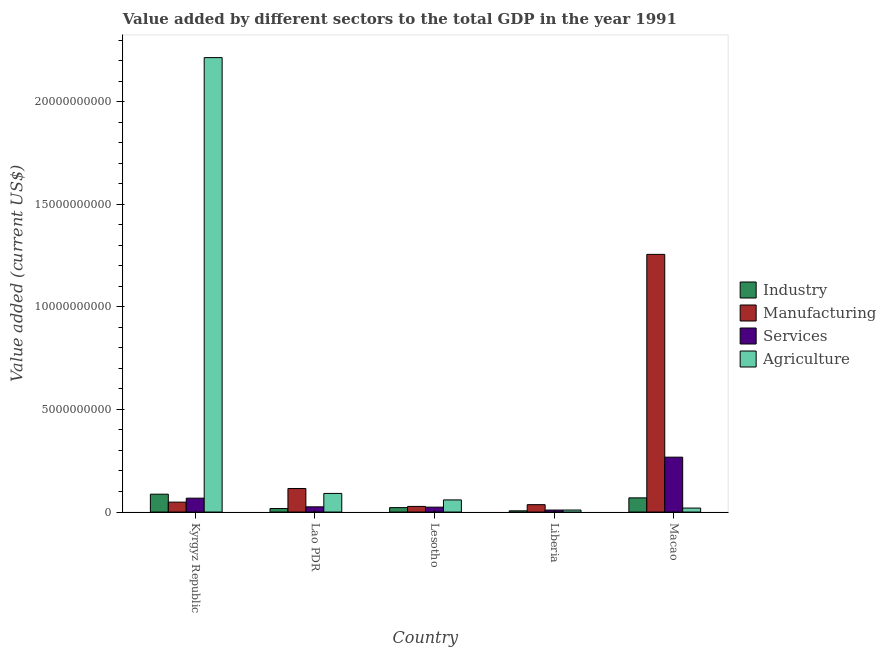Are the number of bars per tick equal to the number of legend labels?
Ensure brevity in your answer.  Yes. How many bars are there on the 3rd tick from the left?
Keep it short and to the point. 4. What is the label of the 5th group of bars from the left?
Provide a short and direct response. Macao. What is the value added by manufacturing sector in Lesotho?
Offer a very short reply. 2.74e+08. Across all countries, what is the maximum value added by agricultural sector?
Offer a terse response. 2.21e+1. Across all countries, what is the minimum value added by agricultural sector?
Offer a terse response. 9.75e+07. In which country was the value added by industrial sector maximum?
Make the answer very short. Kyrgyz Republic. In which country was the value added by industrial sector minimum?
Keep it short and to the point. Liberia. What is the total value added by agricultural sector in the graph?
Offer a very short reply. 2.39e+1. What is the difference between the value added by manufacturing sector in Kyrgyz Republic and that in Liberia?
Keep it short and to the point. 1.23e+08. What is the difference between the value added by agricultural sector in Macao and the value added by services sector in Kyrgyz Republic?
Your response must be concise. -4.82e+08. What is the average value added by industrial sector per country?
Your answer should be very brief. 4.01e+08. What is the difference between the value added by manufacturing sector and value added by agricultural sector in Macao?
Ensure brevity in your answer.  1.24e+1. In how many countries, is the value added by agricultural sector greater than 5000000000 US$?
Your response must be concise. 1. What is the ratio of the value added by industrial sector in Lao PDR to that in Liberia?
Offer a very short reply. 2.92. What is the difference between the highest and the second highest value added by agricultural sector?
Offer a terse response. 2.12e+1. What is the difference between the highest and the lowest value added by agricultural sector?
Provide a short and direct response. 2.20e+1. Is the sum of the value added by industrial sector in Lao PDR and Macao greater than the maximum value added by services sector across all countries?
Make the answer very short. No. What does the 1st bar from the left in Macao represents?
Your answer should be very brief. Industry. What does the 1st bar from the right in Lao PDR represents?
Keep it short and to the point. Agriculture. How many bars are there?
Your response must be concise. 20. Does the graph contain any zero values?
Your answer should be compact. No. Does the graph contain grids?
Provide a succinct answer. No. Where does the legend appear in the graph?
Your answer should be compact. Center right. What is the title of the graph?
Offer a very short reply. Value added by different sectors to the total GDP in the year 1991. Does "Salary of employees" appear as one of the legend labels in the graph?
Offer a terse response. No. What is the label or title of the Y-axis?
Make the answer very short. Value added (current US$). What is the Value added (current US$) of Industry in Kyrgyz Republic?
Make the answer very short. 8.69e+08. What is the Value added (current US$) of Manufacturing in Kyrgyz Republic?
Make the answer very short. 4.82e+08. What is the Value added (current US$) in Services in Kyrgyz Republic?
Provide a short and direct response. 6.76e+08. What is the Value added (current US$) in Agriculture in Kyrgyz Republic?
Your answer should be very brief. 2.21e+1. What is the Value added (current US$) in Industry in Lao PDR?
Your answer should be very brief. 1.70e+08. What is the Value added (current US$) in Manufacturing in Lao PDR?
Provide a succinct answer. 1.15e+09. What is the Value added (current US$) in Services in Lao PDR?
Offer a terse response. 2.53e+08. What is the Value added (current US$) in Agriculture in Lao PDR?
Provide a short and direct response. 9.06e+08. What is the Value added (current US$) of Industry in Lesotho?
Keep it short and to the point. 2.15e+08. What is the Value added (current US$) of Manufacturing in Lesotho?
Provide a short and direct response. 2.74e+08. What is the Value added (current US$) in Services in Lesotho?
Your response must be concise. 2.38e+08. What is the Value added (current US$) of Agriculture in Lesotho?
Keep it short and to the point. 5.90e+08. What is the Value added (current US$) of Industry in Liberia?
Give a very brief answer. 5.83e+07. What is the Value added (current US$) in Manufacturing in Liberia?
Your answer should be very brief. 3.59e+08. What is the Value added (current US$) in Services in Liberia?
Keep it short and to the point. 9.62e+07. What is the Value added (current US$) of Agriculture in Liberia?
Your answer should be very brief. 9.75e+07. What is the Value added (current US$) in Industry in Macao?
Your answer should be very brief. 6.91e+08. What is the Value added (current US$) in Manufacturing in Macao?
Keep it short and to the point. 1.26e+1. What is the Value added (current US$) in Services in Macao?
Provide a short and direct response. 2.67e+09. What is the Value added (current US$) of Agriculture in Macao?
Provide a succinct answer. 1.94e+08. Across all countries, what is the maximum Value added (current US$) in Industry?
Make the answer very short. 8.69e+08. Across all countries, what is the maximum Value added (current US$) of Manufacturing?
Offer a terse response. 1.26e+1. Across all countries, what is the maximum Value added (current US$) in Services?
Offer a very short reply. 2.67e+09. Across all countries, what is the maximum Value added (current US$) in Agriculture?
Your answer should be very brief. 2.21e+1. Across all countries, what is the minimum Value added (current US$) in Industry?
Provide a short and direct response. 5.83e+07. Across all countries, what is the minimum Value added (current US$) in Manufacturing?
Your response must be concise. 2.74e+08. Across all countries, what is the minimum Value added (current US$) in Services?
Give a very brief answer. 9.62e+07. Across all countries, what is the minimum Value added (current US$) in Agriculture?
Offer a very short reply. 9.75e+07. What is the total Value added (current US$) of Industry in the graph?
Provide a short and direct response. 2.00e+09. What is the total Value added (current US$) in Manufacturing in the graph?
Make the answer very short. 1.48e+1. What is the total Value added (current US$) in Services in the graph?
Ensure brevity in your answer.  3.94e+09. What is the total Value added (current US$) of Agriculture in the graph?
Your answer should be compact. 2.39e+1. What is the difference between the Value added (current US$) in Industry in Kyrgyz Republic and that in Lao PDR?
Offer a very short reply. 6.99e+08. What is the difference between the Value added (current US$) of Manufacturing in Kyrgyz Republic and that in Lao PDR?
Offer a very short reply. -6.65e+08. What is the difference between the Value added (current US$) in Services in Kyrgyz Republic and that in Lao PDR?
Provide a short and direct response. 4.23e+08. What is the difference between the Value added (current US$) in Agriculture in Kyrgyz Republic and that in Lao PDR?
Ensure brevity in your answer.  2.12e+1. What is the difference between the Value added (current US$) of Industry in Kyrgyz Republic and that in Lesotho?
Make the answer very short. 6.54e+08. What is the difference between the Value added (current US$) of Manufacturing in Kyrgyz Republic and that in Lesotho?
Your answer should be compact. 2.08e+08. What is the difference between the Value added (current US$) of Services in Kyrgyz Republic and that in Lesotho?
Provide a short and direct response. 4.38e+08. What is the difference between the Value added (current US$) in Agriculture in Kyrgyz Republic and that in Lesotho?
Keep it short and to the point. 2.16e+1. What is the difference between the Value added (current US$) in Industry in Kyrgyz Republic and that in Liberia?
Offer a terse response. 8.11e+08. What is the difference between the Value added (current US$) in Manufacturing in Kyrgyz Republic and that in Liberia?
Offer a very short reply. 1.23e+08. What is the difference between the Value added (current US$) of Services in Kyrgyz Republic and that in Liberia?
Provide a short and direct response. 5.80e+08. What is the difference between the Value added (current US$) of Agriculture in Kyrgyz Republic and that in Liberia?
Your answer should be compact. 2.20e+1. What is the difference between the Value added (current US$) in Industry in Kyrgyz Republic and that in Macao?
Provide a succinct answer. 1.78e+08. What is the difference between the Value added (current US$) of Manufacturing in Kyrgyz Republic and that in Macao?
Make the answer very short. -1.21e+1. What is the difference between the Value added (current US$) of Services in Kyrgyz Republic and that in Macao?
Provide a succinct answer. -2.00e+09. What is the difference between the Value added (current US$) in Agriculture in Kyrgyz Republic and that in Macao?
Provide a short and direct response. 2.20e+1. What is the difference between the Value added (current US$) of Industry in Lao PDR and that in Lesotho?
Keep it short and to the point. -4.48e+07. What is the difference between the Value added (current US$) of Manufacturing in Lao PDR and that in Lesotho?
Provide a short and direct response. 8.73e+08. What is the difference between the Value added (current US$) of Services in Lao PDR and that in Lesotho?
Give a very brief answer. 1.51e+07. What is the difference between the Value added (current US$) of Agriculture in Lao PDR and that in Lesotho?
Provide a succinct answer. 3.16e+08. What is the difference between the Value added (current US$) of Industry in Lao PDR and that in Liberia?
Give a very brief answer. 1.12e+08. What is the difference between the Value added (current US$) of Manufacturing in Lao PDR and that in Liberia?
Make the answer very short. 7.89e+08. What is the difference between the Value added (current US$) of Services in Lao PDR and that in Liberia?
Give a very brief answer. 1.57e+08. What is the difference between the Value added (current US$) of Agriculture in Lao PDR and that in Liberia?
Your answer should be compact. 8.09e+08. What is the difference between the Value added (current US$) in Industry in Lao PDR and that in Macao?
Your response must be concise. -5.20e+08. What is the difference between the Value added (current US$) in Manufacturing in Lao PDR and that in Macao?
Your answer should be very brief. -1.14e+1. What is the difference between the Value added (current US$) in Services in Lao PDR and that in Macao?
Offer a terse response. -2.42e+09. What is the difference between the Value added (current US$) of Agriculture in Lao PDR and that in Macao?
Offer a very short reply. 7.13e+08. What is the difference between the Value added (current US$) in Industry in Lesotho and that in Liberia?
Provide a succinct answer. 1.57e+08. What is the difference between the Value added (current US$) in Manufacturing in Lesotho and that in Liberia?
Keep it short and to the point. -8.49e+07. What is the difference between the Value added (current US$) of Services in Lesotho and that in Liberia?
Provide a short and direct response. 1.42e+08. What is the difference between the Value added (current US$) in Agriculture in Lesotho and that in Liberia?
Give a very brief answer. 4.93e+08. What is the difference between the Value added (current US$) in Industry in Lesotho and that in Macao?
Keep it short and to the point. -4.75e+08. What is the difference between the Value added (current US$) in Manufacturing in Lesotho and that in Macao?
Your response must be concise. -1.23e+1. What is the difference between the Value added (current US$) in Services in Lesotho and that in Macao?
Provide a succinct answer. -2.44e+09. What is the difference between the Value added (current US$) of Agriculture in Lesotho and that in Macao?
Your response must be concise. 3.97e+08. What is the difference between the Value added (current US$) of Industry in Liberia and that in Macao?
Keep it short and to the point. -6.32e+08. What is the difference between the Value added (current US$) in Manufacturing in Liberia and that in Macao?
Offer a very short reply. -1.22e+1. What is the difference between the Value added (current US$) in Services in Liberia and that in Macao?
Your response must be concise. -2.58e+09. What is the difference between the Value added (current US$) in Agriculture in Liberia and that in Macao?
Keep it short and to the point. -9.60e+07. What is the difference between the Value added (current US$) in Industry in Kyrgyz Republic and the Value added (current US$) in Manufacturing in Lao PDR?
Your response must be concise. -2.78e+08. What is the difference between the Value added (current US$) in Industry in Kyrgyz Republic and the Value added (current US$) in Services in Lao PDR?
Your response must be concise. 6.16e+08. What is the difference between the Value added (current US$) in Industry in Kyrgyz Republic and the Value added (current US$) in Agriculture in Lao PDR?
Provide a succinct answer. -3.73e+07. What is the difference between the Value added (current US$) of Manufacturing in Kyrgyz Republic and the Value added (current US$) of Services in Lao PDR?
Offer a terse response. 2.29e+08. What is the difference between the Value added (current US$) in Manufacturing in Kyrgyz Republic and the Value added (current US$) in Agriculture in Lao PDR?
Your answer should be compact. -4.24e+08. What is the difference between the Value added (current US$) in Services in Kyrgyz Republic and the Value added (current US$) in Agriculture in Lao PDR?
Provide a succinct answer. -2.31e+08. What is the difference between the Value added (current US$) in Industry in Kyrgyz Republic and the Value added (current US$) in Manufacturing in Lesotho?
Your answer should be very brief. 5.95e+08. What is the difference between the Value added (current US$) in Industry in Kyrgyz Republic and the Value added (current US$) in Services in Lesotho?
Your answer should be very brief. 6.31e+08. What is the difference between the Value added (current US$) in Industry in Kyrgyz Republic and the Value added (current US$) in Agriculture in Lesotho?
Make the answer very short. 2.79e+08. What is the difference between the Value added (current US$) of Manufacturing in Kyrgyz Republic and the Value added (current US$) of Services in Lesotho?
Offer a very short reply. 2.44e+08. What is the difference between the Value added (current US$) of Manufacturing in Kyrgyz Republic and the Value added (current US$) of Agriculture in Lesotho?
Provide a short and direct response. -1.08e+08. What is the difference between the Value added (current US$) of Services in Kyrgyz Republic and the Value added (current US$) of Agriculture in Lesotho?
Provide a short and direct response. 8.53e+07. What is the difference between the Value added (current US$) in Industry in Kyrgyz Republic and the Value added (current US$) in Manufacturing in Liberia?
Your response must be concise. 5.10e+08. What is the difference between the Value added (current US$) of Industry in Kyrgyz Republic and the Value added (current US$) of Services in Liberia?
Offer a terse response. 7.73e+08. What is the difference between the Value added (current US$) in Industry in Kyrgyz Republic and the Value added (current US$) in Agriculture in Liberia?
Offer a terse response. 7.72e+08. What is the difference between the Value added (current US$) of Manufacturing in Kyrgyz Republic and the Value added (current US$) of Services in Liberia?
Offer a very short reply. 3.86e+08. What is the difference between the Value added (current US$) of Manufacturing in Kyrgyz Republic and the Value added (current US$) of Agriculture in Liberia?
Your answer should be compact. 3.85e+08. What is the difference between the Value added (current US$) in Services in Kyrgyz Republic and the Value added (current US$) in Agriculture in Liberia?
Make the answer very short. 5.78e+08. What is the difference between the Value added (current US$) in Industry in Kyrgyz Republic and the Value added (current US$) in Manufacturing in Macao?
Keep it short and to the point. -1.17e+1. What is the difference between the Value added (current US$) in Industry in Kyrgyz Republic and the Value added (current US$) in Services in Macao?
Offer a very short reply. -1.80e+09. What is the difference between the Value added (current US$) in Industry in Kyrgyz Republic and the Value added (current US$) in Agriculture in Macao?
Provide a succinct answer. 6.76e+08. What is the difference between the Value added (current US$) in Manufacturing in Kyrgyz Republic and the Value added (current US$) in Services in Macao?
Your answer should be compact. -2.19e+09. What is the difference between the Value added (current US$) in Manufacturing in Kyrgyz Republic and the Value added (current US$) in Agriculture in Macao?
Keep it short and to the point. 2.89e+08. What is the difference between the Value added (current US$) of Services in Kyrgyz Republic and the Value added (current US$) of Agriculture in Macao?
Your answer should be compact. 4.82e+08. What is the difference between the Value added (current US$) in Industry in Lao PDR and the Value added (current US$) in Manufacturing in Lesotho?
Your answer should be very brief. -1.04e+08. What is the difference between the Value added (current US$) of Industry in Lao PDR and the Value added (current US$) of Services in Lesotho?
Provide a short and direct response. -6.74e+07. What is the difference between the Value added (current US$) in Industry in Lao PDR and the Value added (current US$) in Agriculture in Lesotho?
Keep it short and to the point. -4.20e+08. What is the difference between the Value added (current US$) of Manufacturing in Lao PDR and the Value added (current US$) of Services in Lesotho?
Keep it short and to the point. 9.10e+08. What is the difference between the Value added (current US$) in Manufacturing in Lao PDR and the Value added (current US$) in Agriculture in Lesotho?
Provide a succinct answer. 5.57e+08. What is the difference between the Value added (current US$) of Services in Lao PDR and the Value added (current US$) of Agriculture in Lesotho?
Offer a very short reply. -3.37e+08. What is the difference between the Value added (current US$) in Industry in Lao PDR and the Value added (current US$) in Manufacturing in Liberia?
Your answer should be compact. -1.89e+08. What is the difference between the Value added (current US$) in Industry in Lao PDR and the Value added (current US$) in Services in Liberia?
Keep it short and to the point. 7.43e+07. What is the difference between the Value added (current US$) of Industry in Lao PDR and the Value added (current US$) of Agriculture in Liberia?
Make the answer very short. 7.30e+07. What is the difference between the Value added (current US$) of Manufacturing in Lao PDR and the Value added (current US$) of Services in Liberia?
Provide a succinct answer. 1.05e+09. What is the difference between the Value added (current US$) of Manufacturing in Lao PDR and the Value added (current US$) of Agriculture in Liberia?
Your response must be concise. 1.05e+09. What is the difference between the Value added (current US$) of Services in Lao PDR and the Value added (current US$) of Agriculture in Liberia?
Make the answer very short. 1.55e+08. What is the difference between the Value added (current US$) of Industry in Lao PDR and the Value added (current US$) of Manufacturing in Macao?
Offer a very short reply. -1.24e+1. What is the difference between the Value added (current US$) of Industry in Lao PDR and the Value added (current US$) of Services in Macao?
Keep it short and to the point. -2.50e+09. What is the difference between the Value added (current US$) of Industry in Lao PDR and the Value added (current US$) of Agriculture in Macao?
Provide a short and direct response. -2.30e+07. What is the difference between the Value added (current US$) of Manufacturing in Lao PDR and the Value added (current US$) of Services in Macao?
Your answer should be compact. -1.53e+09. What is the difference between the Value added (current US$) in Manufacturing in Lao PDR and the Value added (current US$) in Agriculture in Macao?
Your answer should be compact. 9.54e+08. What is the difference between the Value added (current US$) of Services in Lao PDR and the Value added (current US$) of Agriculture in Macao?
Give a very brief answer. 5.95e+07. What is the difference between the Value added (current US$) of Industry in Lesotho and the Value added (current US$) of Manufacturing in Liberia?
Make the answer very short. -1.44e+08. What is the difference between the Value added (current US$) in Industry in Lesotho and the Value added (current US$) in Services in Liberia?
Provide a short and direct response. 1.19e+08. What is the difference between the Value added (current US$) of Industry in Lesotho and the Value added (current US$) of Agriculture in Liberia?
Your answer should be compact. 1.18e+08. What is the difference between the Value added (current US$) of Manufacturing in Lesotho and the Value added (current US$) of Services in Liberia?
Provide a short and direct response. 1.78e+08. What is the difference between the Value added (current US$) in Manufacturing in Lesotho and the Value added (current US$) in Agriculture in Liberia?
Provide a succinct answer. 1.77e+08. What is the difference between the Value added (current US$) in Services in Lesotho and the Value added (current US$) in Agriculture in Liberia?
Provide a succinct answer. 1.40e+08. What is the difference between the Value added (current US$) of Industry in Lesotho and the Value added (current US$) of Manufacturing in Macao?
Give a very brief answer. -1.23e+1. What is the difference between the Value added (current US$) of Industry in Lesotho and the Value added (current US$) of Services in Macao?
Keep it short and to the point. -2.46e+09. What is the difference between the Value added (current US$) of Industry in Lesotho and the Value added (current US$) of Agriculture in Macao?
Your response must be concise. 2.18e+07. What is the difference between the Value added (current US$) in Manufacturing in Lesotho and the Value added (current US$) in Services in Macao?
Offer a terse response. -2.40e+09. What is the difference between the Value added (current US$) of Manufacturing in Lesotho and the Value added (current US$) of Agriculture in Macao?
Make the answer very short. 8.07e+07. What is the difference between the Value added (current US$) in Services in Lesotho and the Value added (current US$) in Agriculture in Macao?
Ensure brevity in your answer.  4.44e+07. What is the difference between the Value added (current US$) in Industry in Liberia and the Value added (current US$) in Manufacturing in Macao?
Your answer should be very brief. -1.25e+1. What is the difference between the Value added (current US$) in Industry in Liberia and the Value added (current US$) in Services in Macao?
Provide a short and direct response. -2.62e+09. What is the difference between the Value added (current US$) in Industry in Liberia and the Value added (current US$) in Agriculture in Macao?
Offer a very short reply. -1.35e+08. What is the difference between the Value added (current US$) in Manufacturing in Liberia and the Value added (current US$) in Services in Macao?
Give a very brief answer. -2.31e+09. What is the difference between the Value added (current US$) of Manufacturing in Liberia and the Value added (current US$) of Agriculture in Macao?
Offer a terse response. 1.66e+08. What is the difference between the Value added (current US$) in Services in Liberia and the Value added (current US$) in Agriculture in Macao?
Make the answer very short. -9.73e+07. What is the average Value added (current US$) in Industry per country?
Offer a very short reply. 4.01e+08. What is the average Value added (current US$) of Manufacturing per country?
Your answer should be very brief. 2.96e+09. What is the average Value added (current US$) in Services per country?
Keep it short and to the point. 7.87e+08. What is the average Value added (current US$) of Agriculture per country?
Offer a very short reply. 4.79e+09. What is the difference between the Value added (current US$) of Industry and Value added (current US$) of Manufacturing in Kyrgyz Republic?
Your answer should be compact. 3.87e+08. What is the difference between the Value added (current US$) of Industry and Value added (current US$) of Services in Kyrgyz Republic?
Keep it short and to the point. 1.93e+08. What is the difference between the Value added (current US$) in Industry and Value added (current US$) in Agriculture in Kyrgyz Republic?
Offer a terse response. -2.13e+1. What is the difference between the Value added (current US$) in Manufacturing and Value added (current US$) in Services in Kyrgyz Republic?
Your answer should be compact. -1.94e+08. What is the difference between the Value added (current US$) of Manufacturing and Value added (current US$) of Agriculture in Kyrgyz Republic?
Give a very brief answer. -2.17e+1. What is the difference between the Value added (current US$) in Services and Value added (current US$) in Agriculture in Kyrgyz Republic?
Provide a succinct answer. -2.15e+1. What is the difference between the Value added (current US$) of Industry and Value added (current US$) of Manufacturing in Lao PDR?
Provide a succinct answer. -9.77e+08. What is the difference between the Value added (current US$) in Industry and Value added (current US$) in Services in Lao PDR?
Provide a short and direct response. -8.25e+07. What is the difference between the Value added (current US$) of Industry and Value added (current US$) of Agriculture in Lao PDR?
Your answer should be compact. -7.36e+08. What is the difference between the Value added (current US$) in Manufacturing and Value added (current US$) in Services in Lao PDR?
Make the answer very short. 8.95e+08. What is the difference between the Value added (current US$) of Manufacturing and Value added (current US$) of Agriculture in Lao PDR?
Offer a terse response. 2.41e+08. What is the difference between the Value added (current US$) in Services and Value added (current US$) in Agriculture in Lao PDR?
Offer a very short reply. -6.53e+08. What is the difference between the Value added (current US$) in Industry and Value added (current US$) in Manufacturing in Lesotho?
Offer a very short reply. -5.89e+07. What is the difference between the Value added (current US$) of Industry and Value added (current US$) of Services in Lesotho?
Offer a very short reply. -2.26e+07. What is the difference between the Value added (current US$) in Industry and Value added (current US$) in Agriculture in Lesotho?
Make the answer very short. -3.75e+08. What is the difference between the Value added (current US$) of Manufacturing and Value added (current US$) of Services in Lesotho?
Provide a succinct answer. 3.63e+07. What is the difference between the Value added (current US$) of Manufacturing and Value added (current US$) of Agriculture in Lesotho?
Offer a terse response. -3.16e+08. What is the difference between the Value added (current US$) of Services and Value added (current US$) of Agriculture in Lesotho?
Your response must be concise. -3.52e+08. What is the difference between the Value added (current US$) in Industry and Value added (current US$) in Manufacturing in Liberia?
Keep it short and to the point. -3.01e+08. What is the difference between the Value added (current US$) in Industry and Value added (current US$) in Services in Liberia?
Offer a very short reply. -3.79e+07. What is the difference between the Value added (current US$) of Industry and Value added (current US$) of Agriculture in Liberia?
Keep it short and to the point. -3.92e+07. What is the difference between the Value added (current US$) of Manufacturing and Value added (current US$) of Services in Liberia?
Give a very brief answer. 2.63e+08. What is the difference between the Value added (current US$) of Manufacturing and Value added (current US$) of Agriculture in Liberia?
Make the answer very short. 2.62e+08. What is the difference between the Value added (current US$) in Services and Value added (current US$) in Agriculture in Liberia?
Your answer should be compact. -1.33e+06. What is the difference between the Value added (current US$) of Industry and Value added (current US$) of Manufacturing in Macao?
Provide a short and direct response. -1.19e+1. What is the difference between the Value added (current US$) in Industry and Value added (current US$) in Services in Macao?
Your answer should be compact. -1.98e+09. What is the difference between the Value added (current US$) in Industry and Value added (current US$) in Agriculture in Macao?
Give a very brief answer. 4.97e+08. What is the difference between the Value added (current US$) of Manufacturing and Value added (current US$) of Services in Macao?
Offer a terse response. 9.88e+09. What is the difference between the Value added (current US$) of Manufacturing and Value added (current US$) of Agriculture in Macao?
Provide a short and direct response. 1.24e+1. What is the difference between the Value added (current US$) in Services and Value added (current US$) in Agriculture in Macao?
Ensure brevity in your answer.  2.48e+09. What is the ratio of the Value added (current US$) of Industry in Kyrgyz Republic to that in Lao PDR?
Your response must be concise. 5.1. What is the ratio of the Value added (current US$) of Manufacturing in Kyrgyz Republic to that in Lao PDR?
Ensure brevity in your answer.  0.42. What is the ratio of the Value added (current US$) in Services in Kyrgyz Republic to that in Lao PDR?
Make the answer very short. 2.67. What is the ratio of the Value added (current US$) of Agriculture in Kyrgyz Republic to that in Lao PDR?
Offer a very short reply. 24.43. What is the ratio of the Value added (current US$) of Industry in Kyrgyz Republic to that in Lesotho?
Make the answer very short. 4.04. What is the ratio of the Value added (current US$) of Manufacturing in Kyrgyz Republic to that in Lesotho?
Your response must be concise. 1.76. What is the ratio of the Value added (current US$) in Services in Kyrgyz Republic to that in Lesotho?
Offer a terse response. 2.84. What is the ratio of the Value added (current US$) in Agriculture in Kyrgyz Republic to that in Lesotho?
Offer a terse response. 37.51. What is the ratio of the Value added (current US$) of Industry in Kyrgyz Republic to that in Liberia?
Your response must be concise. 14.91. What is the ratio of the Value added (current US$) of Manufacturing in Kyrgyz Republic to that in Liberia?
Provide a short and direct response. 1.34. What is the ratio of the Value added (current US$) of Services in Kyrgyz Republic to that in Liberia?
Keep it short and to the point. 7.02. What is the ratio of the Value added (current US$) of Agriculture in Kyrgyz Republic to that in Liberia?
Your answer should be very brief. 227.07. What is the ratio of the Value added (current US$) of Industry in Kyrgyz Republic to that in Macao?
Your answer should be very brief. 1.26. What is the ratio of the Value added (current US$) of Manufacturing in Kyrgyz Republic to that in Macao?
Ensure brevity in your answer.  0.04. What is the ratio of the Value added (current US$) of Services in Kyrgyz Republic to that in Macao?
Your answer should be very brief. 0.25. What is the ratio of the Value added (current US$) in Agriculture in Kyrgyz Republic to that in Macao?
Ensure brevity in your answer.  114.45. What is the ratio of the Value added (current US$) in Industry in Lao PDR to that in Lesotho?
Your answer should be very brief. 0.79. What is the ratio of the Value added (current US$) of Manufacturing in Lao PDR to that in Lesotho?
Give a very brief answer. 4.19. What is the ratio of the Value added (current US$) in Services in Lao PDR to that in Lesotho?
Your response must be concise. 1.06. What is the ratio of the Value added (current US$) of Agriculture in Lao PDR to that in Lesotho?
Provide a succinct answer. 1.54. What is the ratio of the Value added (current US$) in Industry in Lao PDR to that in Liberia?
Offer a very short reply. 2.92. What is the ratio of the Value added (current US$) of Manufacturing in Lao PDR to that in Liberia?
Keep it short and to the point. 3.2. What is the ratio of the Value added (current US$) in Services in Lao PDR to that in Liberia?
Ensure brevity in your answer.  2.63. What is the ratio of the Value added (current US$) in Agriculture in Lao PDR to that in Liberia?
Your answer should be compact. 9.29. What is the ratio of the Value added (current US$) in Industry in Lao PDR to that in Macao?
Keep it short and to the point. 0.25. What is the ratio of the Value added (current US$) of Manufacturing in Lao PDR to that in Macao?
Your answer should be compact. 0.09. What is the ratio of the Value added (current US$) in Services in Lao PDR to that in Macao?
Your answer should be very brief. 0.09. What is the ratio of the Value added (current US$) in Agriculture in Lao PDR to that in Macao?
Make the answer very short. 4.68. What is the ratio of the Value added (current US$) in Industry in Lesotho to that in Liberia?
Ensure brevity in your answer.  3.69. What is the ratio of the Value added (current US$) of Manufacturing in Lesotho to that in Liberia?
Keep it short and to the point. 0.76. What is the ratio of the Value added (current US$) of Services in Lesotho to that in Liberia?
Provide a short and direct response. 2.47. What is the ratio of the Value added (current US$) in Agriculture in Lesotho to that in Liberia?
Your answer should be very brief. 6.05. What is the ratio of the Value added (current US$) of Industry in Lesotho to that in Macao?
Your answer should be very brief. 0.31. What is the ratio of the Value added (current US$) in Manufacturing in Lesotho to that in Macao?
Keep it short and to the point. 0.02. What is the ratio of the Value added (current US$) in Services in Lesotho to that in Macao?
Offer a terse response. 0.09. What is the ratio of the Value added (current US$) in Agriculture in Lesotho to that in Macao?
Offer a very short reply. 3.05. What is the ratio of the Value added (current US$) in Industry in Liberia to that in Macao?
Provide a succinct answer. 0.08. What is the ratio of the Value added (current US$) of Manufacturing in Liberia to that in Macao?
Make the answer very short. 0.03. What is the ratio of the Value added (current US$) in Services in Liberia to that in Macao?
Offer a terse response. 0.04. What is the ratio of the Value added (current US$) of Agriculture in Liberia to that in Macao?
Offer a terse response. 0.5. What is the difference between the highest and the second highest Value added (current US$) in Industry?
Offer a very short reply. 1.78e+08. What is the difference between the highest and the second highest Value added (current US$) of Manufacturing?
Keep it short and to the point. 1.14e+1. What is the difference between the highest and the second highest Value added (current US$) in Services?
Keep it short and to the point. 2.00e+09. What is the difference between the highest and the second highest Value added (current US$) in Agriculture?
Offer a very short reply. 2.12e+1. What is the difference between the highest and the lowest Value added (current US$) in Industry?
Make the answer very short. 8.11e+08. What is the difference between the highest and the lowest Value added (current US$) in Manufacturing?
Ensure brevity in your answer.  1.23e+1. What is the difference between the highest and the lowest Value added (current US$) of Services?
Provide a short and direct response. 2.58e+09. What is the difference between the highest and the lowest Value added (current US$) of Agriculture?
Give a very brief answer. 2.20e+1. 